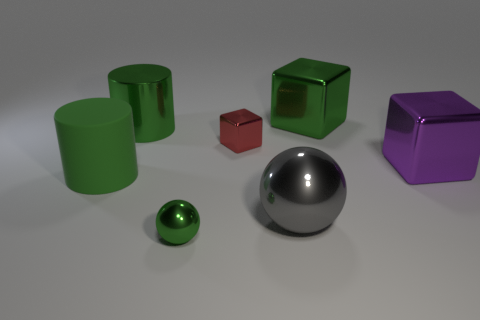There is a green metal thing that is in front of the rubber object; is its shape the same as the purple object?
Give a very brief answer. No. The other thing that is the same shape as the gray metallic thing is what color?
Offer a terse response. Green. What is the size of the green thing that is the same shape as the small red thing?
Give a very brief answer. Large. What is the material of the object that is behind the green sphere and in front of the big green matte object?
Provide a succinct answer. Metal. Do the small metal block on the right side of the tiny green sphere and the small metal ball have the same color?
Make the answer very short. No. Do the matte object and the small sphere that is left of the red metallic block have the same color?
Ensure brevity in your answer.  Yes. Are there any big green objects right of the tiny red metallic object?
Provide a succinct answer. Yes. Is the material of the green cube the same as the large gray ball?
Offer a very short reply. Yes. There is a green cube that is the same size as the rubber cylinder; what is its material?
Make the answer very short. Metal. How many things are big green objects that are to the left of the green metal sphere or gray metallic objects?
Your response must be concise. 3. 